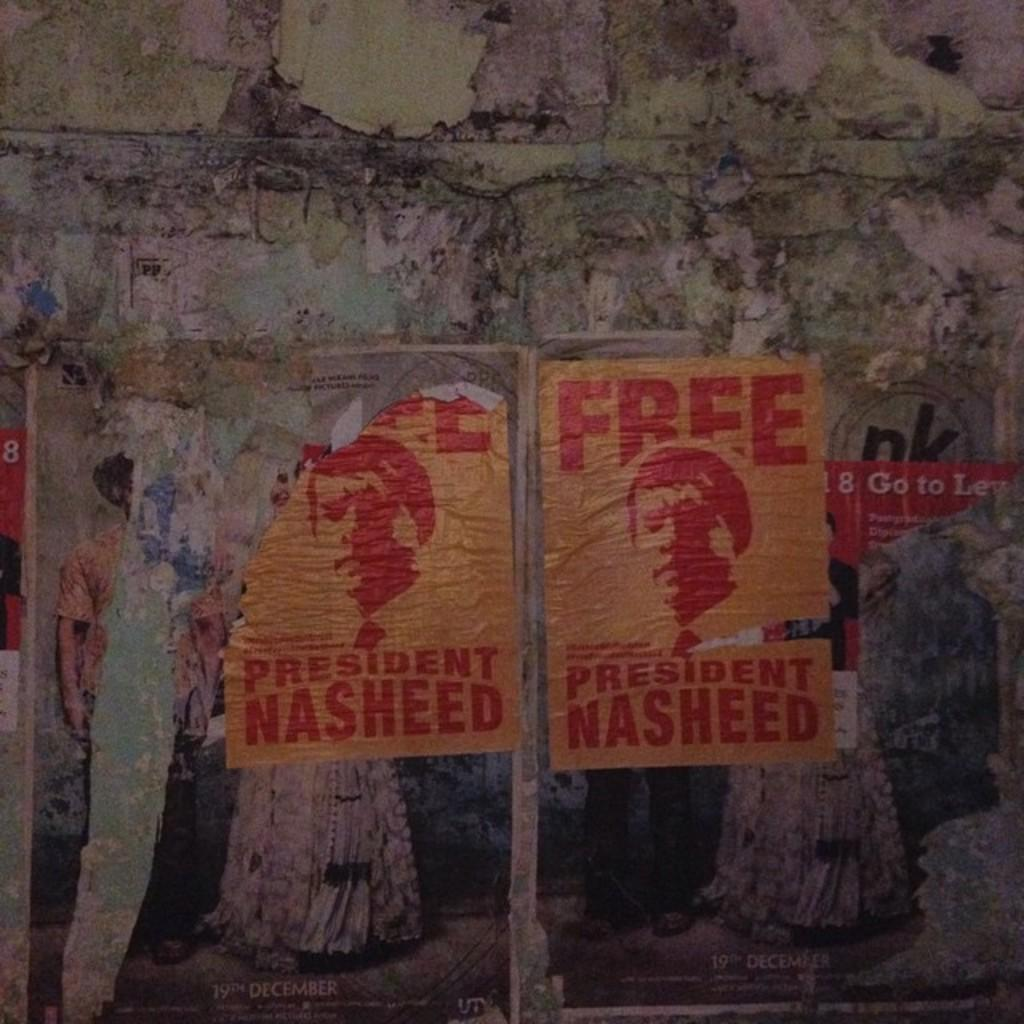<image>
Describe the image concisely. Two posters for President Nasheed suck onto a rock wall. 